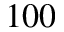Convert formula to latex. <formula><loc_0><loc_0><loc_500><loc_500>1 0 0</formula> 